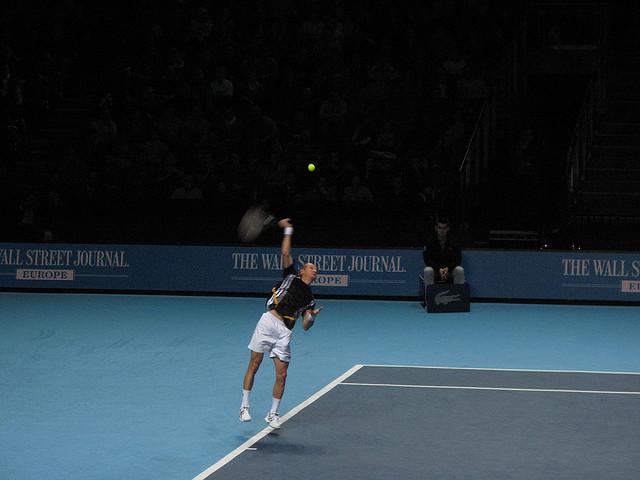Is the ball ascending or descending?
Quick response, please. Descending. What time is on the clock?
Keep it brief. No clock. Is the man holding the ball?
Answer briefly. No. Is there a clock in this picture?
Write a very short answer. No. What color are the mans shorts?
Keep it brief. White. Is the ball arriving or departing the racket of this athlete?
Concise answer only. Arriving. What tennis stroke is the man using?
Give a very brief answer. Serve. What is the person playing?
Answer briefly. Tennis. Is there text in the top right corner of this picture?
Write a very short answer. No. Is the player jumping?
Be succinct. Yes. Why is the shadow cast?
Be succinct. Lighting. 